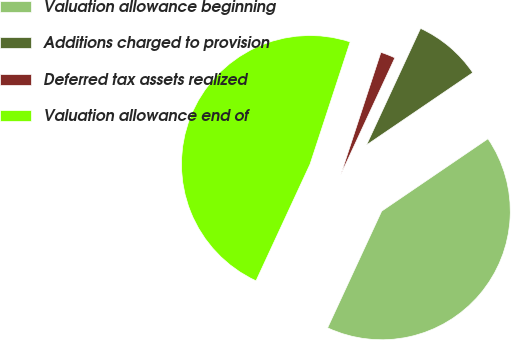<chart> <loc_0><loc_0><loc_500><loc_500><pie_chart><fcel>Valuation allowance beginning<fcel>Additions charged to provision<fcel>Deferred tax assets realized<fcel>Valuation allowance end of<nl><fcel>41.42%<fcel>8.58%<fcel>1.86%<fcel>48.14%<nl></chart> 